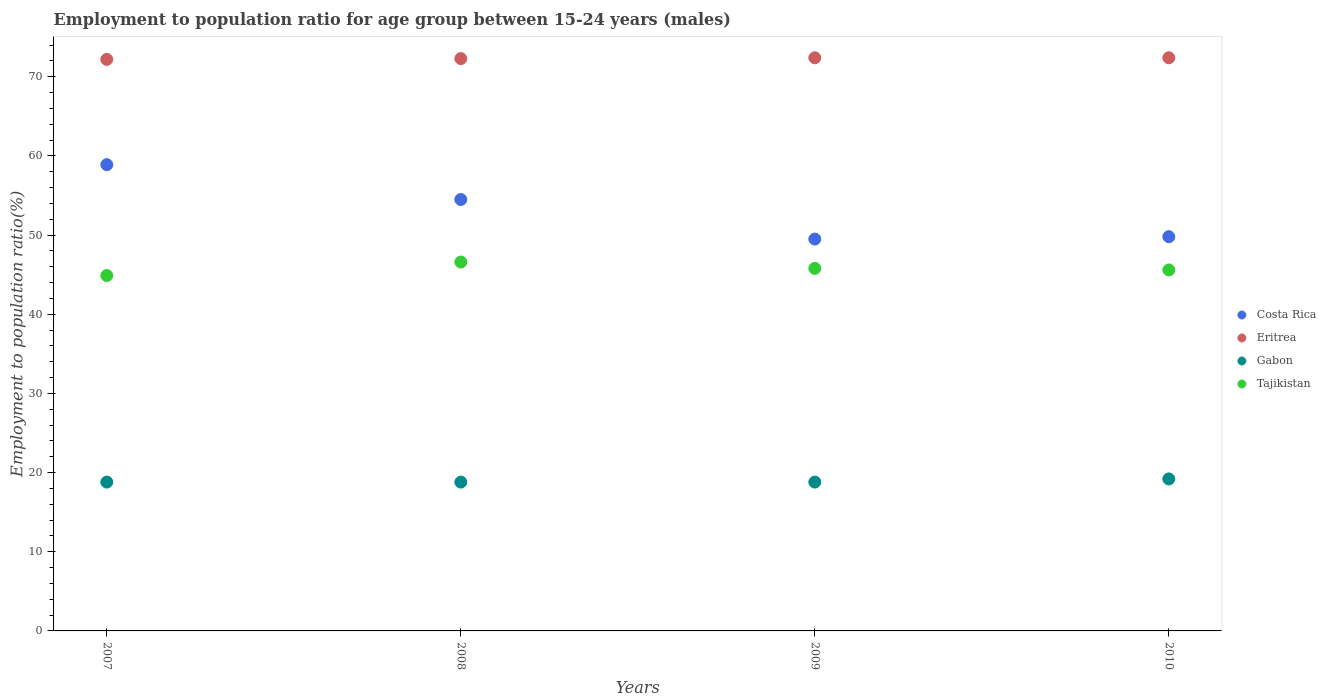What is the employment to population ratio in Eritrea in 2007?
Make the answer very short. 72.2. Across all years, what is the maximum employment to population ratio in Costa Rica?
Give a very brief answer. 58.9. Across all years, what is the minimum employment to population ratio in Eritrea?
Provide a short and direct response. 72.2. In which year was the employment to population ratio in Tajikistan maximum?
Your answer should be very brief. 2008. What is the total employment to population ratio in Tajikistan in the graph?
Your response must be concise. 182.9. What is the difference between the employment to population ratio in Eritrea in 2007 and that in 2008?
Provide a succinct answer. -0.1. What is the difference between the employment to population ratio in Tajikistan in 2008 and the employment to population ratio in Gabon in 2009?
Provide a succinct answer. 27.8. What is the average employment to population ratio in Gabon per year?
Make the answer very short. 18.9. In the year 2010, what is the difference between the employment to population ratio in Eritrea and employment to population ratio in Tajikistan?
Your response must be concise. 26.8. What is the ratio of the employment to population ratio in Costa Rica in 2007 to that in 2008?
Give a very brief answer. 1.08. Is the employment to population ratio in Eritrea in 2007 less than that in 2009?
Your answer should be compact. Yes. Is the difference between the employment to population ratio in Eritrea in 2007 and 2010 greater than the difference between the employment to population ratio in Tajikistan in 2007 and 2010?
Provide a short and direct response. Yes. What is the difference between the highest and the lowest employment to population ratio in Costa Rica?
Provide a succinct answer. 9.4. In how many years, is the employment to population ratio in Costa Rica greater than the average employment to population ratio in Costa Rica taken over all years?
Provide a short and direct response. 2. Is it the case that in every year, the sum of the employment to population ratio in Eritrea and employment to population ratio in Tajikistan  is greater than the sum of employment to population ratio in Gabon and employment to population ratio in Costa Rica?
Make the answer very short. Yes. Is it the case that in every year, the sum of the employment to population ratio in Gabon and employment to population ratio in Costa Rica  is greater than the employment to population ratio in Tajikistan?
Provide a succinct answer. Yes. Does the employment to population ratio in Tajikistan monotonically increase over the years?
Offer a very short reply. No. How many years are there in the graph?
Give a very brief answer. 4. Are the values on the major ticks of Y-axis written in scientific E-notation?
Provide a short and direct response. No. Where does the legend appear in the graph?
Your answer should be compact. Center right. How are the legend labels stacked?
Keep it short and to the point. Vertical. What is the title of the graph?
Provide a succinct answer. Employment to population ratio for age group between 15-24 years (males). Does "French Polynesia" appear as one of the legend labels in the graph?
Your answer should be very brief. No. What is the label or title of the X-axis?
Give a very brief answer. Years. What is the label or title of the Y-axis?
Make the answer very short. Employment to population ratio(%). What is the Employment to population ratio(%) in Costa Rica in 2007?
Your response must be concise. 58.9. What is the Employment to population ratio(%) in Eritrea in 2007?
Make the answer very short. 72.2. What is the Employment to population ratio(%) of Gabon in 2007?
Offer a very short reply. 18.8. What is the Employment to population ratio(%) of Tajikistan in 2007?
Make the answer very short. 44.9. What is the Employment to population ratio(%) in Costa Rica in 2008?
Your answer should be very brief. 54.5. What is the Employment to population ratio(%) of Eritrea in 2008?
Your answer should be compact. 72.3. What is the Employment to population ratio(%) in Gabon in 2008?
Make the answer very short. 18.8. What is the Employment to population ratio(%) of Tajikistan in 2008?
Your answer should be very brief. 46.6. What is the Employment to population ratio(%) of Costa Rica in 2009?
Your response must be concise. 49.5. What is the Employment to population ratio(%) of Eritrea in 2009?
Your answer should be compact. 72.4. What is the Employment to population ratio(%) in Gabon in 2009?
Provide a succinct answer. 18.8. What is the Employment to population ratio(%) of Tajikistan in 2009?
Your answer should be compact. 45.8. What is the Employment to population ratio(%) in Costa Rica in 2010?
Provide a short and direct response. 49.8. What is the Employment to population ratio(%) in Eritrea in 2010?
Provide a short and direct response. 72.4. What is the Employment to population ratio(%) in Gabon in 2010?
Provide a short and direct response. 19.2. What is the Employment to population ratio(%) in Tajikistan in 2010?
Provide a succinct answer. 45.6. Across all years, what is the maximum Employment to population ratio(%) of Costa Rica?
Offer a terse response. 58.9. Across all years, what is the maximum Employment to population ratio(%) of Eritrea?
Your answer should be compact. 72.4. Across all years, what is the maximum Employment to population ratio(%) of Gabon?
Your answer should be very brief. 19.2. Across all years, what is the maximum Employment to population ratio(%) in Tajikistan?
Offer a terse response. 46.6. Across all years, what is the minimum Employment to population ratio(%) in Costa Rica?
Your answer should be very brief. 49.5. Across all years, what is the minimum Employment to population ratio(%) of Eritrea?
Provide a short and direct response. 72.2. Across all years, what is the minimum Employment to population ratio(%) in Gabon?
Keep it short and to the point. 18.8. Across all years, what is the minimum Employment to population ratio(%) of Tajikistan?
Make the answer very short. 44.9. What is the total Employment to population ratio(%) of Costa Rica in the graph?
Offer a terse response. 212.7. What is the total Employment to population ratio(%) in Eritrea in the graph?
Give a very brief answer. 289.3. What is the total Employment to population ratio(%) in Gabon in the graph?
Provide a short and direct response. 75.6. What is the total Employment to population ratio(%) of Tajikistan in the graph?
Your answer should be very brief. 182.9. What is the difference between the Employment to population ratio(%) in Costa Rica in 2007 and that in 2008?
Your response must be concise. 4.4. What is the difference between the Employment to population ratio(%) in Costa Rica in 2007 and that in 2009?
Offer a very short reply. 9.4. What is the difference between the Employment to population ratio(%) of Eritrea in 2007 and that in 2009?
Ensure brevity in your answer.  -0.2. What is the difference between the Employment to population ratio(%) in Gabon in 2007 and that in 2009?
Make the answer very short. 0. What is the difference between the Employment to population ratio(%) of Costa Rica in 2007 and that in 2010?
Provide a short and direct response. 9.1. What is the difference between the Employment to population ratio(%) in Eritrea in 2007 and that in 2010?
Give a very brief answer. -0.2. What is the difference between the Employment to population ratio(%) of Tajikistan in 2007 and that in 2010?
Give a very brief answer. -0.7. What is the difference between the Employment to population ratio(%) of Tajikistan in 2008 and that in 2009?
Your response must be concise. 0.8. What is the difference between the Employment to population ratio(%) in Costa Rica in 2008 and that in 2010?
Ensure brevity in your answer.  4.7. What is the difference between the Employment to population ratio(%) of Eritrea in 2008 and that in 2010?
Provide a short and direct response. -0.1. What is the difference between the Employment to population ratio(%) in Gabon in 2008 and that in 2010?
Provide a short and direct response. -0.4. What is the difference between the Employment to population ratio(%) of Tajikistan in 2008 and that in 2010?
Offer a very short reply. 1. What is the difference between the Employment to population ratio(%) in Eritrea in 2009 and that in 2010?
Your response must be concise. 0. What is the difference between the Employment to population ratio(%) in Gabon in 2009 and that in 2010?
Give a very brief answer. -0.4. What is the difference between the Employment to population ratio(%) in Costa Rica in 2007 and the Employment to population ratio(%) in Eritrea in 2008?
Offer a very short reply. -13.4. What is the difference between the Employment to population ratio(%) of Costa Rica in 2007 and the Employment to population ratio(%) of Gabon in 2008?
Your answer should be very brief. 40.1. What is the difference between the Employment to population ratio(%) in Costa Rica in 2007 and the Employment to population ratio(%) in Tajikistan in 2008?
Provide a succinct answer. 12.3. What is the difference between the Employment to population ratio(%) of Eritrea in 2007 and the Employment to population ratio(%) of Gabon in 2008?
Your response must be concise. 53.4. What is the difference between the Employment to population ratio(%) of Eritrea in 2007 and the Employment to population ratio(%) of Tajikistan in 2008?
Provide a short and direct response. 25.6. What is the difference between the Employment to population ratio(%) of Gabon in 2007 and the Employment to population ratio(%) of Tajikistan in 2008?
Keep it short and to the point. -27.8. What is the difference between the Employment to population ratio(%) of Costa Rica in 2007 and the Employment to population ratio(%) of Gabon in 2009?
Provide a short and direct response. 40.1. What is the difference between the Employment to population ratio(%) of Eritrea in 2007 and the Employment to population ratio(%) of Gabon in 2009?
Keep it short and to the point. 53.4. What is the difference between the Employment to population ratio(%) of Eritrea in 2007 and the Employment to population ratio(%) of Tajikistan in 2009?
Your answer should be very brief. 26.4. What is the difference between the Employment to population ratio(%) of Costa Rica in 2007 and the Employment to population ratio(%) of Gabon in 2010?
Keep it short and to the point. 39.7. What is the difference between the Employment to population ratio(%) of Costa Rica in 2007 and the Employment to population ratio(%) of Tajikistan in 2010?
Make the answer very short. 13.3. What is the difference between the Employment to population ratio(%) in Eritrea in 2007 and the Employment to population ratio(%) in Tajikistan in 2010?
Your answer should be compact. 26.6. What is the difference between the Employment to population ratio(%) in Gabon in 2007 and the Employment to population ratio(%) in Tajikistan in 2010?
Provide a succinct answer. -26.8. What is the difference between the Employment to population ratio(%) in Costa Rica in 2008 and the Employment to population ratio(%) in Eritrea in 2009?
Offer a terse response. -17.9. What is the difference between the Employment to population ratio(%) of Costa Rica in 2008 and the Employment to population ratio(%) of Gabon in 2009?
Offer a very short reply. 35.7. What is the difference between the Employment to population ratio(%) in Eritrea in 2008 and the Employment to population ratio(%) in Gabon in 2009?
Keep it short and to the point. 53.5. What is the difference between the Employment to population ratio(%) in Gabon in 2008 and the Employment to population ratio(%) in Tajikistan in 2009?
Keep it short and to the point. -27. What is the difference between the Employment to population ratio(%) of Costa Rica in 2008 and the Employment to population ratio(%) of Eritrea in 2010?
Keep it short and to the point. -17.9. What is the difference between the Employment to population ratio(%) in Costa Rica in 2008 and the Employment to population ratio(%) in Gabon in 2010?
Your answer should be very brief. 35.3. What is the difference between the Employment to population ratio(%) of Eritrea in 2008 and the Employment to population ratio(%) of Gabon in 2010?
Your answer should be very brief. 53.1. What is the difference between the Employment to population ratio(%) of Eritrea in 2008 and the Employment to population ratio(%) of Tajikistan in 2010?
Your answer should be very brief. 26.7. What is the difference between the Employment to population ratio(%) of Gabon in 2008 and the Employment to population ratio(%) of Tajikistan in 2010?
Give a very brief answer. -26.8. What is the difference between the Employment to population ratio(%) of Costa Rica in 2009 and the Employment to population ratio(%) of Eritrea in 2010?
Give a very brief answer. -22.9. What is the difference between the Employment to population ratio(%) of Costa Rica in 2009 and the Employment to population ratio(%) of Gabon in 2010?
Your response must be concise. 30.3. What is the difference between the Employment to population ratio(%) of Costa Rica in 2009 and the Employment to population ratio(%) of Tajikistan in 2010?
Offer a very short reply. 3.9. What is the difference between the Employment to population ratio(%) of Eritrea in 2009 and the Employment to population ratio(%) of Gabon in 2010?
Keep it short and to the point. 53.2. What is the difference between the Employment to population ratio(%) in Eritrea in 2009 and the Employment to population ratio(%) in Tajikistan in 2010?
Keep it short and to the point. 26.8. What is the difference between the Employment to population ratio(%) of Gabon in 2009 and the Employment to population ratio(%) of Tajikistan in 2010?
Make the answer very short. -26.8. What is the average Employment to population ratio(%) in Costa Rica per year?
Give a very brief answer. 53.17. What is the average Employment to population ratio(%) in Eritrea per year?
Keep it short and to the point. 72.33. What is the average Employment to population ratio(%) of Tajikistan per year?
Make the answer very short. 45.73. In the year 2007, what is the difference between the Employment to population ratio(%) in Costa Rica and Employment to population ratio(%) in Eritrea?
Your answer should be compact. -13.3. In the year 2007, what is the difference between the Employment to population ratio(%) in Costa Rica and Employment to population ratio(%) in Gabon?
Offer a very short reply. 40.1. In the year 2007, what is the difference between the Employment to population ratio(%) of Costa Rica and Employment to population ratio(%) of Tajikistan?
Your response must be concise. 14. In the year 2007, what is the difference between the Employment to population ratio(%) in Eritrea and Employment to population ratio(%) in Gabon?
Give a very brief answer. 53.4. In the year 2007, what is the difference between the Employment to population ratio(%) of Eritrea and Employment to population ratio(%) of Tajikistan?
Offer a terse response. 27.3. In the year 2007, what is the difference between the Employment to population ratio(%) of Gabon and Employment to population ratio(%) of Tajikistan?
Make the answer very short. -26.1. In the year 2008, what is the difference between the Employment to population ratio(%) in Costa Rica and Employment to population ratio(%) in Eritrea?
Give a very brief answer. -17.8. In the year 2008, what is the difference between the Employment to population ratio(%) in Costa Rica and Employment to population ratio(%) in Gabon?
Your response must be concise. 35.7. In the year 2008, what is the difference between the Employment to population ratio(%) in Costa Rica and Employment to population ratio(%) in Tajikistan?
Offer a terse response. 7.9. In the year 2008, what is the difference between the Employment to population ratio(%) in Eritrea and Employment to population ratio(%) in Gabon?
Give a very brief answer. 53.5. In the year 2008, what is the difference between the Employment to population ratio(%) in Eritrea and Employment to population ratio(%) in Tajikistan?
Ensure brevity in your answer.  25.7. In the year 2008, what is the difference between the Employment to population ratio(%) of Gabon and Employment to population ratio(%) of Tajikistan?
Keep it short and to the point. -27.8. In the year 2009, what is the difference between the Employment to population ratio(%) of Costa Rica and Employment to population ratio(%) of Eritrea?
Your answer should be very brief. -22.9. In the year 2009, what is the difference between the Employment to population ratio(%) in Costa Rica and Employment to population ratio(%) in Gabon?
Provide a succinct answer. 30.7. In the year 2009, what is the difference between the Employment to population ratio(%) in Eritrea and Employment to population ratio(%) in Gabon?
Keep it short and to the point. 53.6. In the year 2009, what is the difference between the Employment to population ratio(%) in Eritrea and Employment to population ratio(%) in Tajikistan?
Your answer should be very brief. 26.6. In the year 2009, what is the difference between the Employment to population ratio(%) in Gabon and Employment to population ratio(%) in Tajikistan?
Offer a terse response. -27. In the year 2010, what is the difference between the Employment to population ratio(%) in Costa Rica and Employment to population ratio(%) in Eritrea?
Your answer should be very brief. -22.6. In the year 2010, what is the difference between the Employment to population ratio(%) in Costa Rica and Employment to population ratio(%) in Gabon?
Your answer should be compact. 30.6. In the year 2010, what is the difference between the Employment to population ratio(%) of Eritrea and Employment to population ratio(%) of Gabon?
Your response must be concise. 53.2. In the year 2010, what is the difference between the Employment to population ratio(%) in Eritrea and Employment to population ratio(%) in Tajikistan?
Give a very brief answer. 26.8. In the year 2010, what is the difference between the Employment to population ratio(%) in Gabon and Employment to population ratio(%) in Tajikistan?
Provide a succinct answer. -26.4. What is the ratio of the Employment to population ratio(%) of Costa Rica in 2007 to that in 2008?
Keep it short and to the point. 1.08. What is the ratio of the Employment to population ratio(%) of Tajikistan in 2007 to that in 2008?
Give a very brief answer. 0.96. What is the ratio of the Employment to population ratio(%) in Costa Rica in 2007 to that in 2009?
Keep it short and to the point. 1.19. What is the ratio of the Employment to population ratio(%) in Eritrea in 2007 to that in 2009?
Your response must be concise. 1. What is the ratio of the Employment to population ratio(%) of Gabon in 2007 to that in 2009?
Ensure brevity in your answer.  1. What is the ratio of the Employment to population ratio(%) of Tajikistan in 2007 to that in 2009?
Keep it short and to the point. 0.98. What is the ratio of the Employment to population ratio(%) in Costa Rica in 2007 to that in 2010?
Provide a succinct answer. 1.18. What is the ratio of the Employment to population ratio(%) of Eritrea in 2007 to that in 2010?
Ensure brevity in your answer.  1. What is the ratio of the Employment to population ratio(%) of Gabon in 2007 to that in 2010?
Your answer should be compact. 0.98. What is the ratio of the Employment to population ratio(%) of Tajikistan in 2007 to that in 2010?
Offer a very short reply. 0.98. What is the ratio of the Employment to population ratio(%) in Costa Rica in 2008 to that in 2009?
Your answer should be very brief. 1.1. What is the ratio of the Employment to population ratio(%) of Eritrea in 2008 to that in 2009?
Make the answer very short. 1. What is the ratio of the Employment to population ratio(%) of Gabon in 2008 to that in 2009?
Your answer should be very brief. 1. What is the ratio of the Employment to population ratio(%) in Tajikistan in 2008 to that in 2009?
Offer a very short reply. 1.02. What is the ratio of the Employment to population ratio(%) of Costa Rica in 2008 to that in 2010?
Give a very brief answer. 1.09. What is the ratio of the Employment to population ratio(%) of Gabon in 2008 to that in 2010?
Your answer should be very brief. 0.98. What is the ratio of the Employment to population ratio(%) in Tajikistan in 2008 to that in 2010?
Ensure brevity in your answer.  1.02. What is the ratio of the Employment to population ratio(%) of Costa Rica in 2009 to that in 2010?
Keep it short and to the point. 0.99. What is the ratio of the Employment to population ratio(%) in Eritrea in 2009 to that in 2010?
Give a very brief answer. 1. What is the ratio of the Employment to population ratio(%) of Gabon in 2009 to that in 2010?
Your answer should be very brief. 0.98. What is the difference between the highest and the second highest Employment to population ratio(%) in Costa Rica?
Offer a terse response. 4.4. What is the difference between the highest and the second highest Employment to population ratio(%) of Eritrea?
Keep it short and to the point. 0. What is the difference between the highest and the second highest Employment to population ratio(%) of Tajikistan?
Offer a very short reply. 0.8. What is the difference between the highest and the lowest Employment to population ratio(%) of Costa Rica?
Ensure brevity in your answer.  9.4. What is the difference between the highest and the lowest Employment to population ratio(%) of Eritrea?
Your answer should be very brief. 0.2. What is the difference between the highest and the lowest Employment to population ratio(%) of Gabon?
Keep it short and to the point. 0.4. What is the difference between the highest and the lowest Employment to population ratio(%) of Tajikistan?
Your answer should be compact. 1.7. 